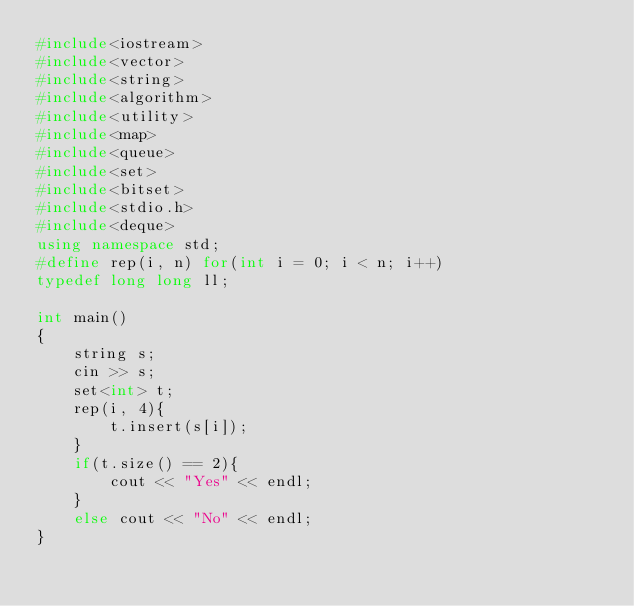<code> <loc_0><loc_0><loc_500><loc_500><_C++_>#include<iostream>
#include<vector>
#include<string>
#include<algorithm>
#include<utility>
#include<map>
#include<queue>
#include<set>
#include<bitset>
#include<stdio.h>
#include<deque>
using namespace std;
#define rep(i, n) for(int i = 0; i < n; i++)
typedef long long ll;
 
int main()
{
    string s;
    cin >> s;
    set<int> t;
    rep(i, 4){
        t.insert(s[i]);
    }
    if(t.size() == 2){
        cout << "Yes" << endl;
    }
    else cout << "No" << endl;
}</code> 